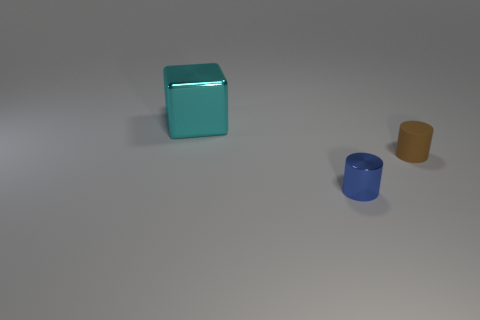Is the number of brown matte objects right of the big block greater than the number of tiny brown objects to the right of the small brown object?
Provide a short and direct response. Yes. What number of cubes are cyan metallic things or tiny brown rubber things?
Offer a very short reply. 1. There is a thing that is in front of the tiny cylinder that is behind the metal cylinder; what number of small objects are behind it?
Make the answer very short. 1. Is the number of tiny gray things greater than the number of blocks?
Your answer should be compact. No. Do the cyan block and the blue cylinder have the same size?
Offer a very short reply. No. How many objects are either big cyan metal blocks or tiny blue shiny cylinders?
Give a very brief answer. 2. What shape is the metal object that is behind the small cylinder that is to the right of the metal object that is in front of the small brown thing?
Your answer should be compact. Cube. Is the object behind the brown object made of the same material as the tiny cylinder that is behind the blue shiny object?
Your answer should be compact. No. There is a small brown object that is the same shape as the tiny blue metallic object; what is its material?
Offer a terse response. Rubber. Is there anything else that has the same size as the blue shiny cylinder?
Offer a very short reply. Yes. 